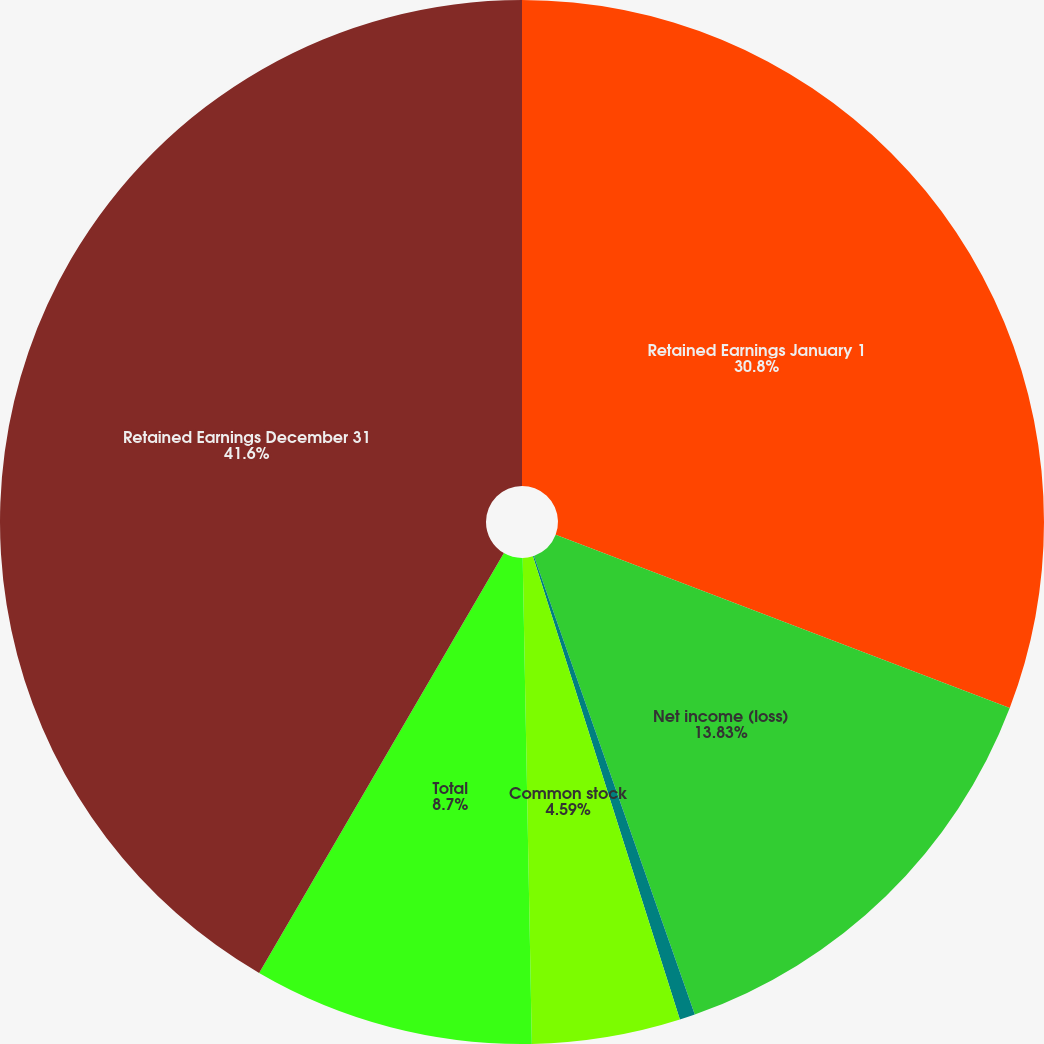Convert chart to OTSL. <chart><loc_0><loc_0><loc_500><loc_500><pie_chart><fcel>Retained Earnings January 1<fcel>Net income (loss)<fcel>Preferred stock<fcel>Common stock<fcel>Total<fcel>Retained Earnings December 31<nl><fcel>30.8%<fcel>13.83%<fcel>0.48%<fcel>4.59%<fcel>8.7%<fcel>41.6%<nl></chart> 